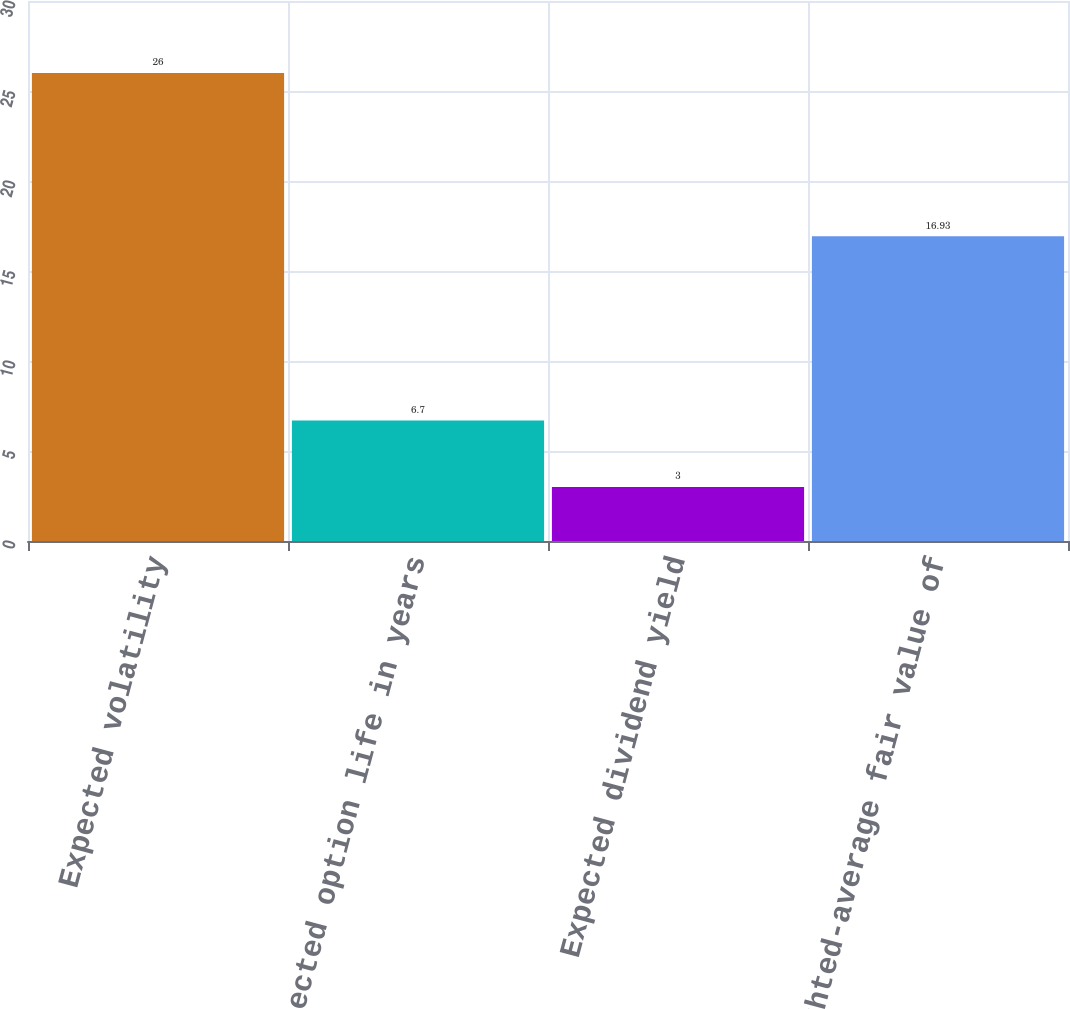Convert chart to OTSL. <chart><loc_0><loc_0><loc_500><loc_500><bar_chart><fcel>Expected volatility<fcel>Expected option life in years<fcel>Expected dividend yield<fcel>Weighted-average fair value of<nl><fcel>26<fcel>6.7<fcel>3<fcel>16.93<nl></chart> 